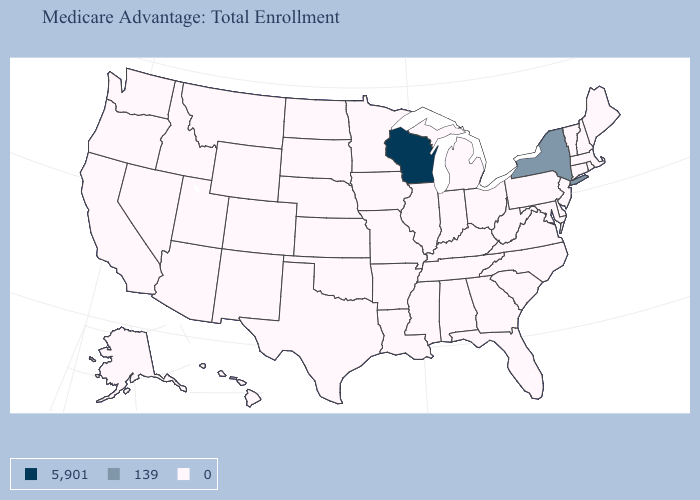What is the value of South Dakota?
Give a very brief answer. 0. Which states hav the highest value in the South?
Short answer required. Alabama, Arkansas, Delaware, Florida, Georgia, Kentucky, Louisiana, Maryland, Mississippi, North Carolina, Oklahoma, South Carolina, Tennessee, Texas, Virginia, West Virginia. What is the lowest value in the Northeast?
Be succinct. 0. What is the lowest value in the USA?
Be succinct. 0. What is the value of Delaware?
Give a very brief answer. 0. Which states have the highest value in the USA?
Answer briefly. Wisconsin. Name the states that have a value in the range 0?
Be succinct. Alabama, Alaska, Arizona, Arkansas, California, Colorado, Connecticut, Delaware, Florida, Georgia, Hawaii, Idaho, Illinois, Indiana, Iowa, Kansas, Kentucky, Louisiana, Maine, Maryland, Massachusetts, Michigan, Minnesota, Mississippi, Missouri, Montana, Nebraska, Nevada, New Hampshire, New Jersey, New Mexico, North Carolina, North Dakota, Ohio, Oklahoma, Oregon, Pennsylvania, Rhode Island, South Carolina, South Dakota, Tennessee, Texas, Utah, Vermont, Virginia, Washington, West Virginia, Wyoming. How many symbols are there in the legend?
Short answer required. 3. What is the highest value in the West ?
Keep it brief. 0. Among the states that border North Dakota , which have the highest value?
Answer briefly. Minnesota, Montana, South Dakota. Name the states that have a value in the range 0?
Be succinct. Alabama, Alaska, Arizona, Arkansas, California, Colorado, Connecticut, Delaware, Florida, Georgia, Hawaii, Idaho, Illinois, Indiana, Iowa, Kansas, Kentucky, Louisiana, Maine, Maryland, Massachusetts, Michigan, Minnesota, Mississippi, Missouri, Montana, Nebraska, Nevada, New Hampshire, New Jersey, New Mexico, North Carolina, North Dakota, Ohio, Oklahoma, Oregon, Pennsylvania, Rhode Island, South Carolina, South Dakota, Tennessee, Texas, Utah, Vermont, Virginia, Washington, West Virginia, Wyoming. Name the states that have a value in the range 0?
Concise answer only. Alabama, Alaska, Arizona, Arkansas, California, Colorado, Connecticut, Delaware, Florida, Georgia, Hawaii, Idaho, Illinois, Indiana, Iowa, Kansas, Kentucky, Louisiana, Maine, Maryland, Massachusetts, Michigan, Minnesota, Mississippi, Missouri, Montana, Nebraska, Nevada, New Hampshire, New Jersey, New Mexico, North Carolina, North Dakota, Ohio, Oklahoma, Oregon, Pennsylvania, Rhode Island, South Carolina, South Dakota, Tennessee, Texas, Utah, Vermont, Virginia, Washington, West Virginia, Wyoming. What is the value of Maryland?
Keep it brief. 0. 